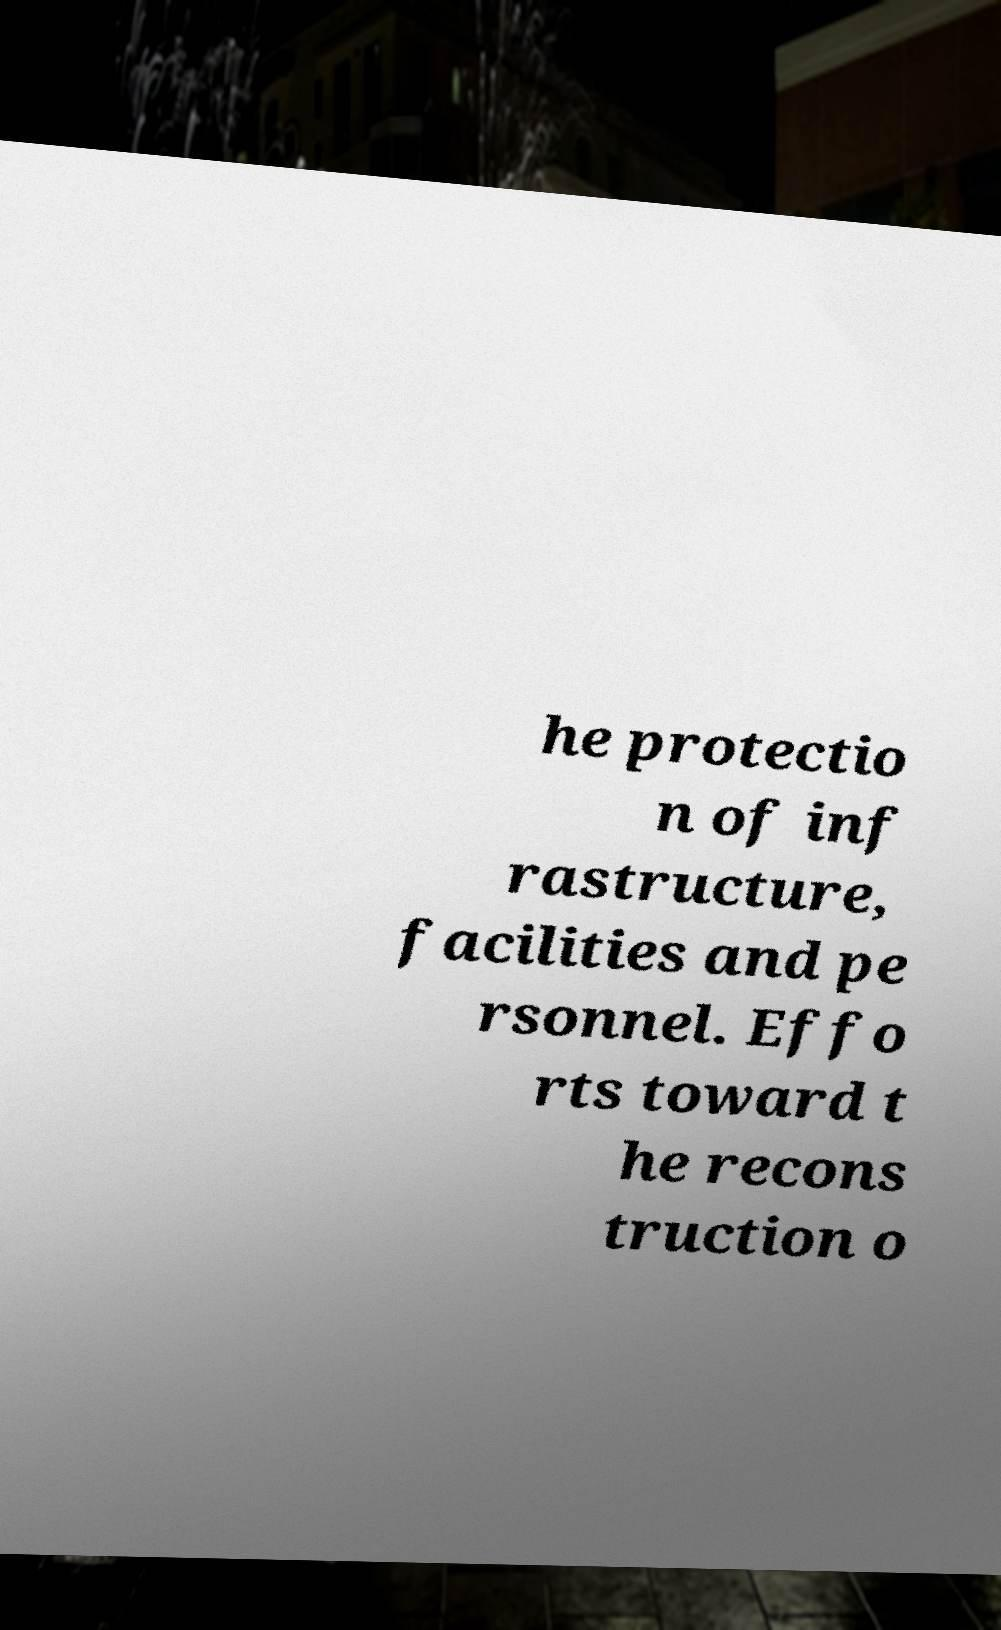For documentation purposes, I need the text within this image transcribed. Could you provide that? he protectio n of inf rastructure, facilities and pe rsonnel. Effo rts toward t he recons truction o 